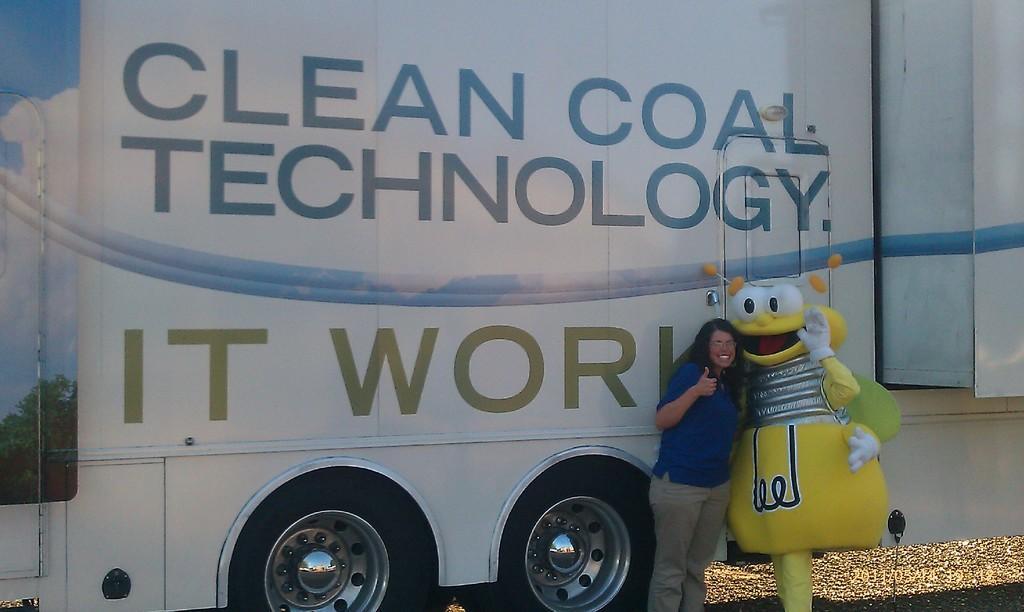In one or two sentences, can you explain what this image depicts? In the background we can see a vehicle. In this picture we can see women wearing a t-shirt and spectacles. She is standing near to a person who is wearing the fancy dress. 